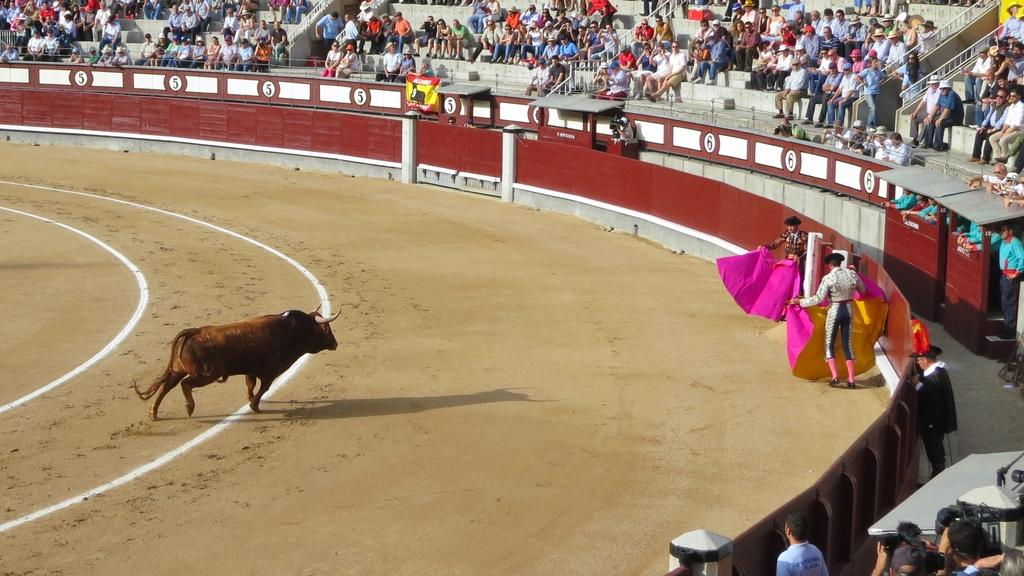What animal is on the ground in the image? There is a bull on the ground in the image. How many people are in the image? There are two persons in the image. What are the two persons wearing? The two persons are wearing hats. What are the two persons holding? The two persons are holding cloth. What can be seen in the background of the image? There is a fence in the image. How many stalks of celery can be seen in the image? There is no celery present in the image. What type of lizards are crawling on the fence in the image? There are no lizards present in the image; the fence is the only visible feature in the background. 